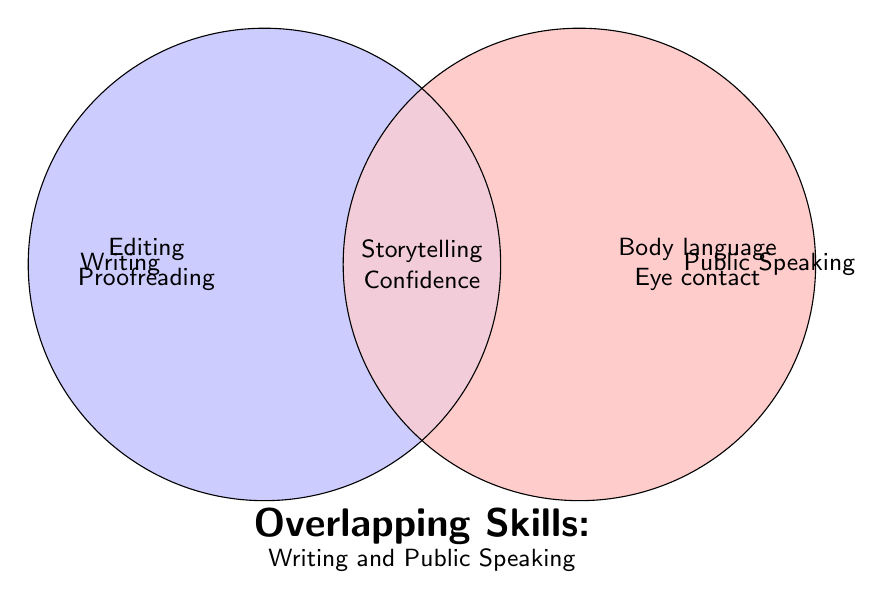What are the main topics in the 'Writing' section? The 'Writing' section lists the skills specific to writing: Editing, Proofreading.
Answer: Editing, Proofreading What skills are shared between writing and public speaking? The overlap between the circles indicates shared skills: Storytelling, Confidence.
Answer: Storytelling, Confidence What are two skills unique to public speaking? The 'Public Speaking' section includes these skills: Body language, Eye contact.
Answer: Body language, Eye contact Which skills belong to the overlapping area of the Venn diagram? The overlapping area includes: Storytelling, Confidence.
Answer: Storytelling, Confidence Compare the numbers of skills listed for writing and public speaking. Which one has more? Writing has two skills listed (Editing, Proofreading) and Public Speaking also has two skills listed (Body language, Eye contact), so they are equal.
Answer: Equal Identify one skill from the 'Writing' section and one from the 'Public Speaking' section. Are any of these skills overlapping? One skill from 'Writing' is Editing, and one from 'Public Speaking' is Eye contact. Neither of these skills overlap.
Answer: No Which section contains the skill 'Proofreading'? The 'Proofreading' skill is listed under the 'Writing' section of the diagram.
Answer: Writing What is the title of the Venn diagram? The title of the Venn diagram is located at the bottom and reads: "Overlapping Skills: Writing and Public Speaking".
Answer: Overlapping Skills: Writing and Public Speaking How many skills are listed in the 'Both' section? The 'Both' section lists two skills: Storytelling and Confidence.
Answer: Two Assess the skill 'Confidence'. Is it found in writing, public speaking, or both? The skill 'Confidence' is found in the overlapping area, indicating it is common to both writing and public speaking.
Answer: Both 